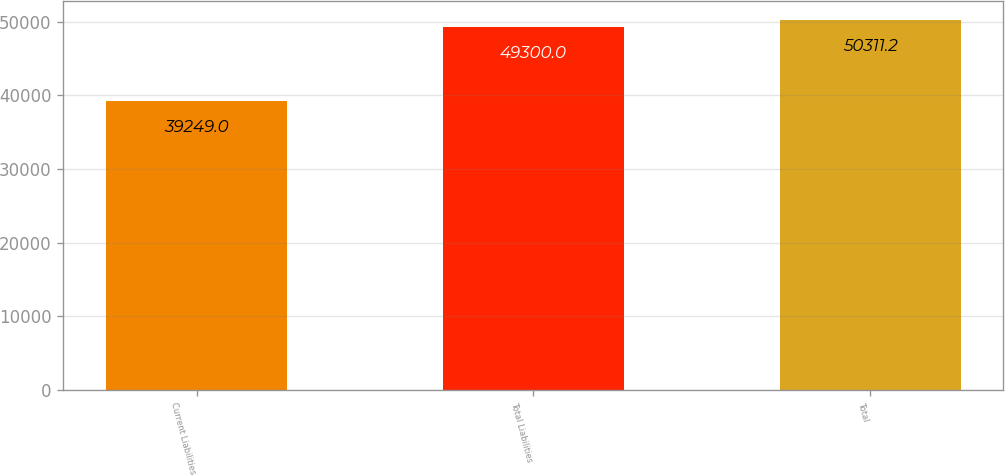Convert chart to OTSL. <chart><loc_0><loc_0><loc_500><loc_500><bar_chart><fcel>Current Liabilities<fcel>Total Liabilities<fcel>Total<nl><fcel>39249<fcel>49300<fcel>50311.2<nl></chart> 